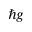Convert formula to latex. <formula><loc_0><loc_0><loc_500><loc_500>\hbar { g }</formula> 